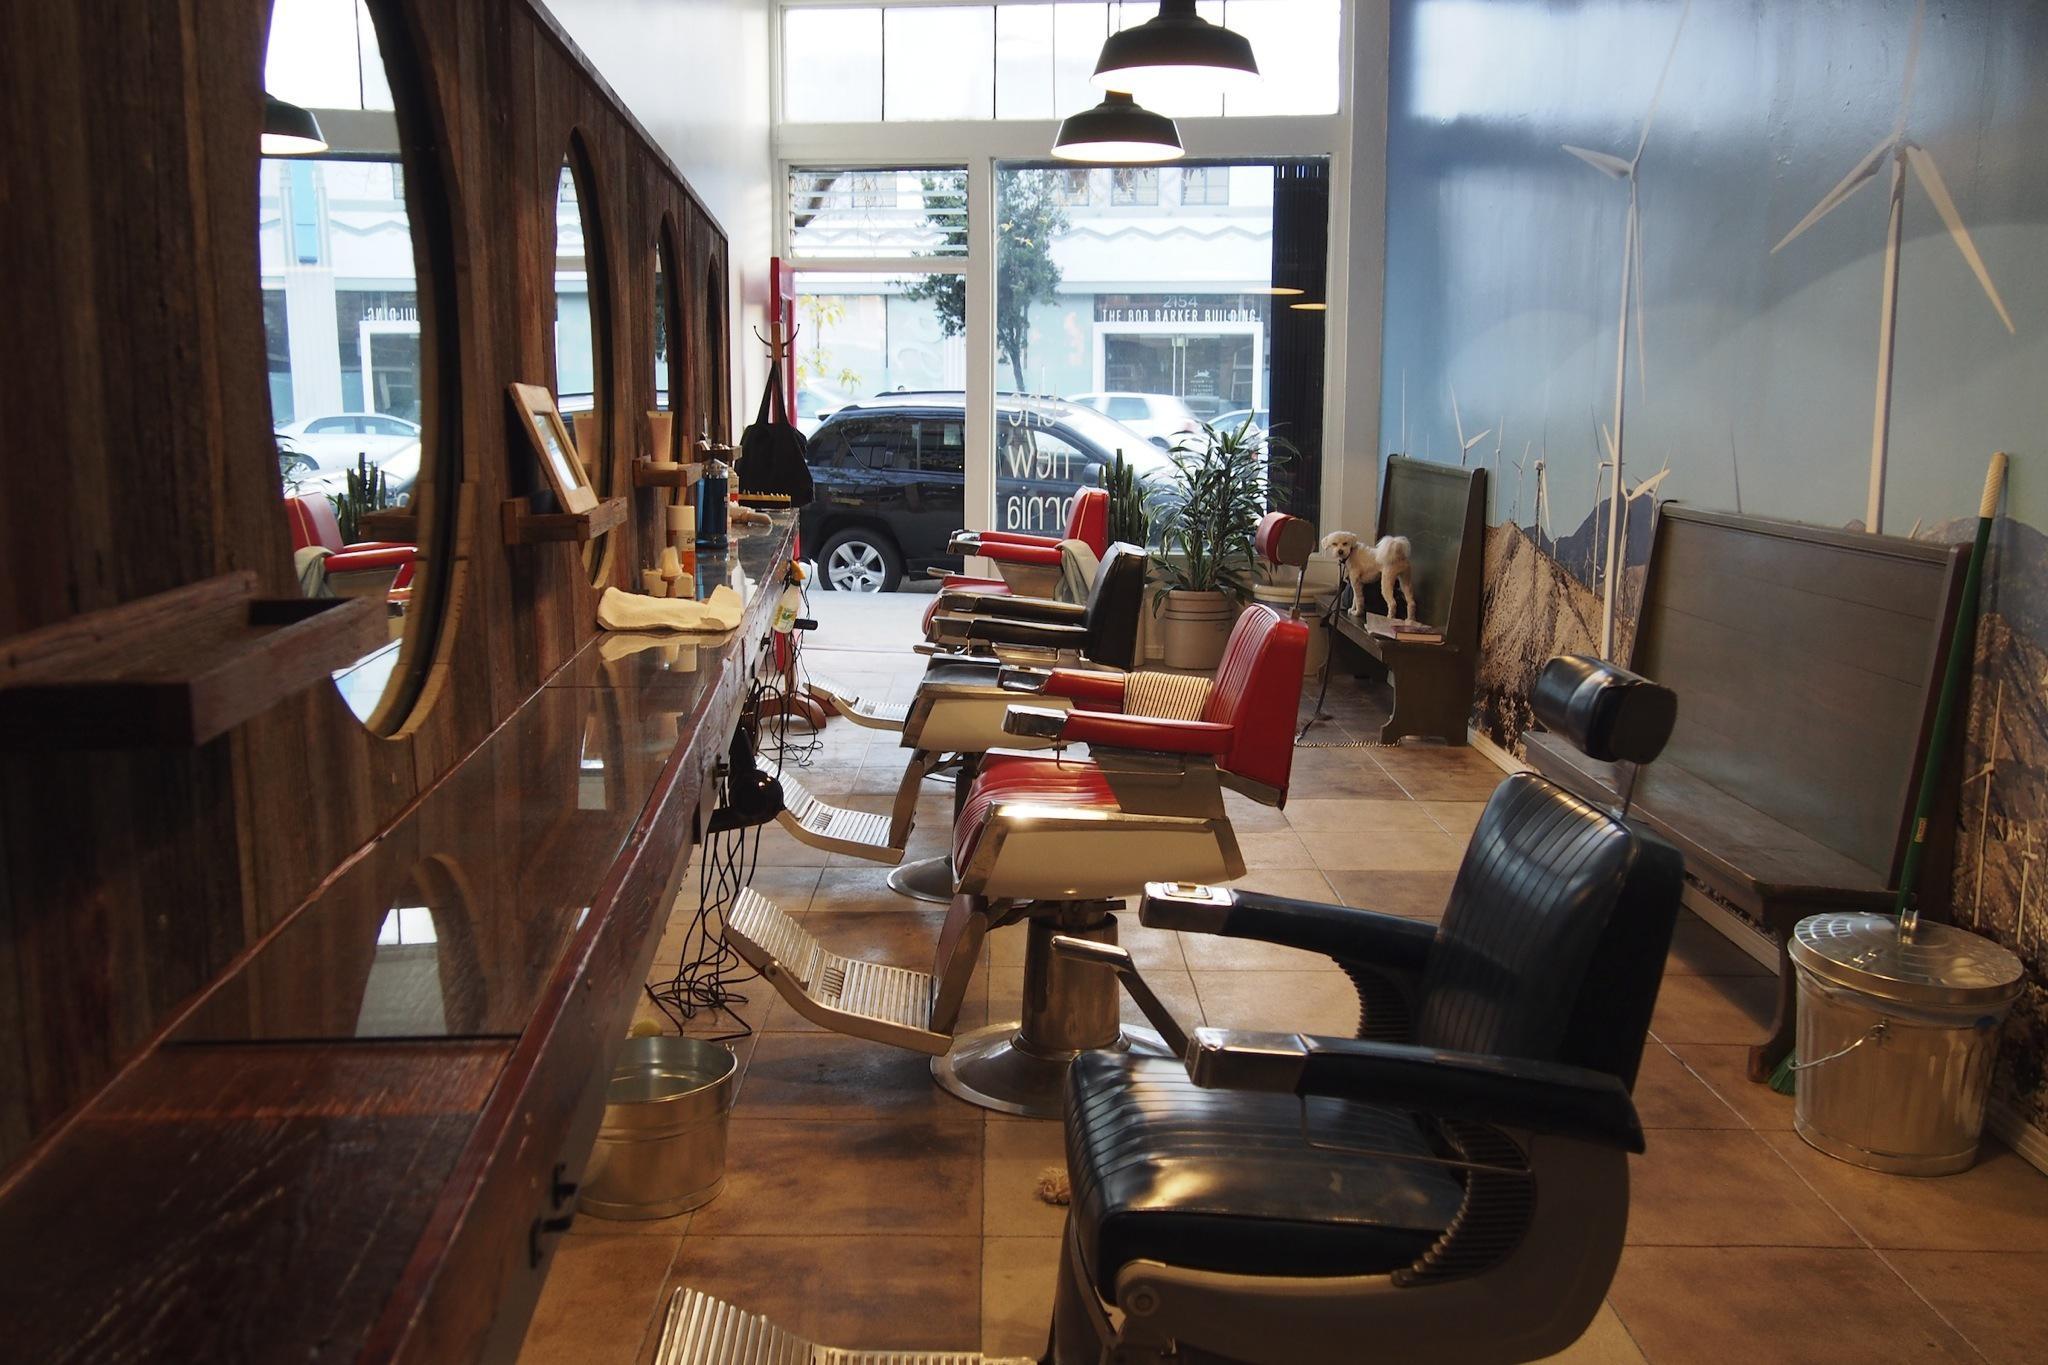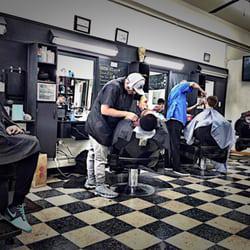The first image is the image on the left, the second image is the image on the right. Evaluate the accuracy of this statement regarding the images: "A barbershop in one image has a row of at least four empty barber chairs, with bench seating at the wall behind.". Is it true? Answer yes or no. Yes. The first image is the image on the left, the second image is the image on the right. Analyze the images presented: Is the assertion "The floor of the barbershop in the image on the right has a checkered pattern." valid? Answer yes or no. Yes. 